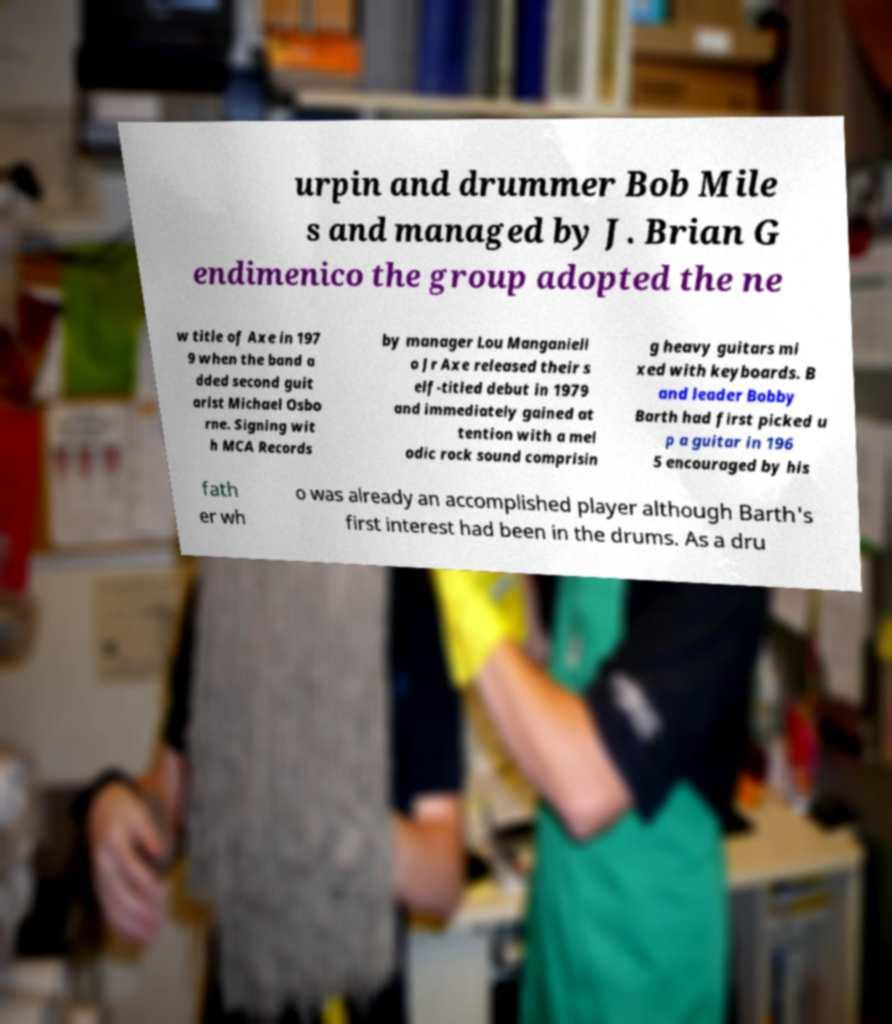Could you assist in decoding the text presented in this image and type it out clearly? urpin and drummer Bob Mile s and managed by J. Brian G endimenico the group adopted the ne w title of Axe in 197 9 when the band a dded second guit arist Michael Osbo rne. Signing wit h MCA Records by manager Lou Manganiell o Jr Axe released their s elf-titled debut in 1979 and immediately gained at tention with a mel odic rock sound comprisin g heavy guitars mi xed with keyboards. B and leader Bobby Barth had first picked u p a guitar in 196 5 encouraged by his fath er wh o was already an accomplished player although Barth's first interest had been in the drums. As a dru 